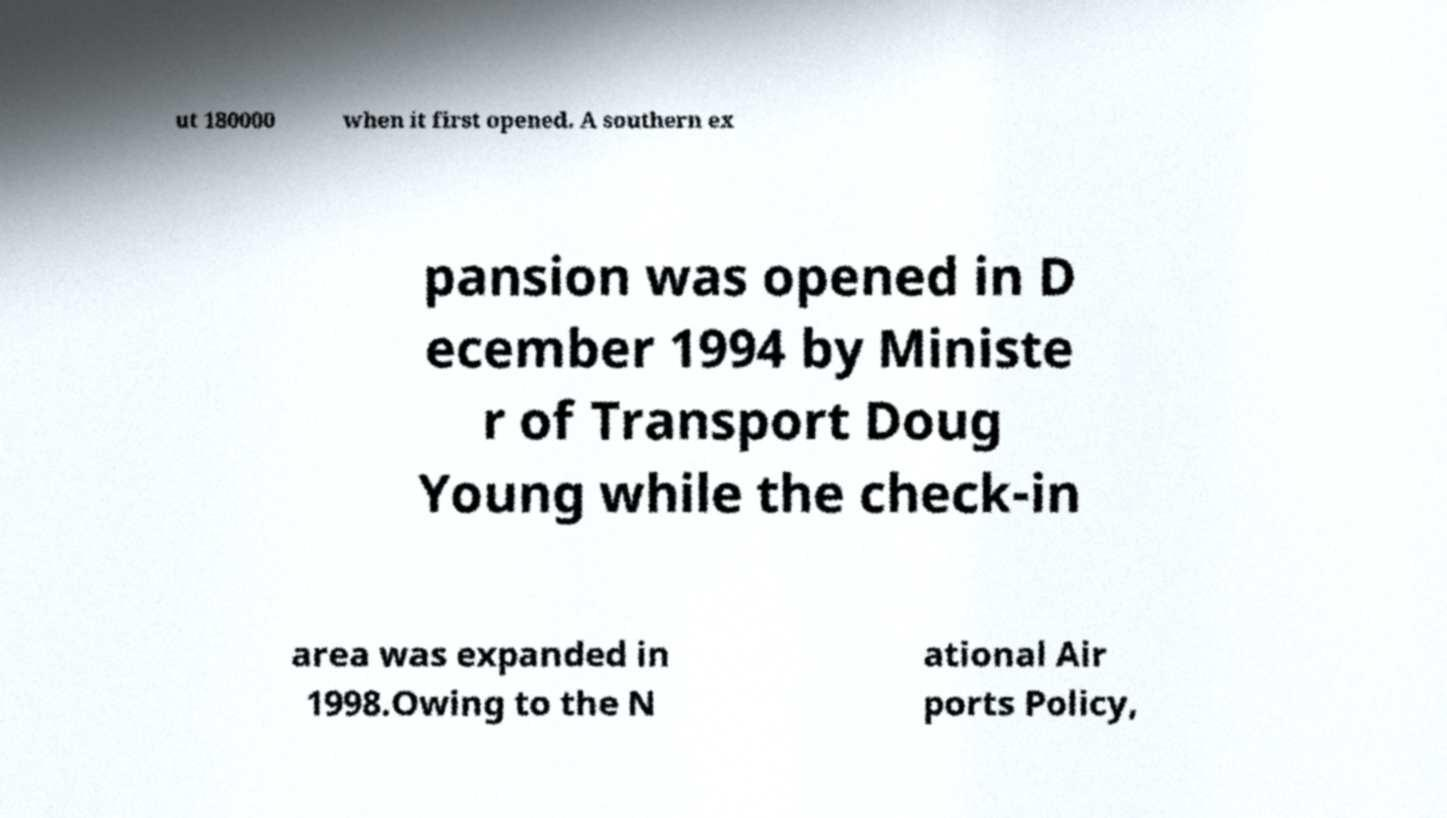Please read and relay the text visible in this image. What does it say? ut 180000 when it first opened. A southern ex pansion was opened in D ecember 1994 by Ministe r of Transport Doug Young while the check-in area was expanded in 1998.Owing to the N ational Air ports Policy, 